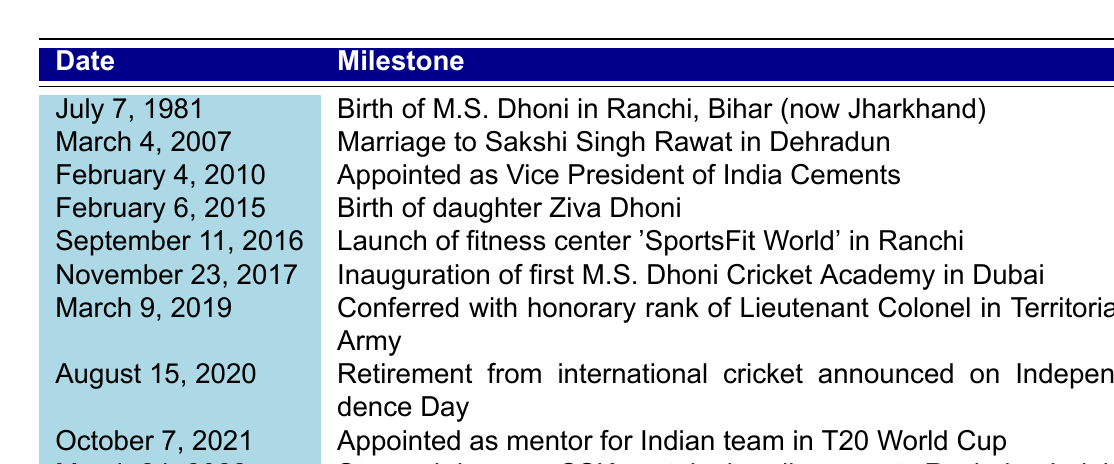What date did M.S. Dhoni get married? The table specifies the date of M.S. Dhoni's marriage as March 4, 2007.
Answer: March 4, 2007 How many years apart are M.S. Dhoni's birth and the birth of his daughter Ziva? M.S. Dhoni was born on July 7, 1981, and Ziva was born on February 6, 2015. The difference in years is 2015 - 1981 = 34 years.
Answer: 34 years Did M.S. Dhoni launch a fitness center? Yes, according to the table, he launched 'SportsFit World' in Ranchi on September 11, 2016.
Answer: Yes When was M.S. Dhoni appointed as Vice President of India Cements? The table shows that M.S. Dhoni was appointed on February 4, 2010.
Answer: February 4, 2010 How many milestones listed happened before 2015? The milestones prior to 2015 are: Birth (1981), Marriage (2007), Vice President appointment (2010), and Ziva's birth (2015). Hence, there are 3 milestones before 2015.
Answer: 3 What was the last major event in M.S. Dhoni's personal life according to the table? The last major event listed is that he stepped down as CSK captain on March 24, 2022.
Answer: March 24, 2022 Was M.S. Dhoni conferred an honorary military rank? Yes, he was conferred the honorary rank of Lieutenant Colonel on March 9, 2019.
Answer: Yes How long after his daughter's birth did he announce his retirement from international cricket? Ziva was born on February 6, 2015, and he retired on August 15, 2020. The duration between these two dates is 5 years and about 6 months.
Answer: 5 years and 6 months What significant career change did M.S. Dhoni undergo on October 7, 2021? On October 7, 2021, he was appointed as a mentor for the Indian team in the T20 World Cup.
Answer: Appointed as mentor for Indian team Which milestone related to cricket academies took place first, and when? The inauguration of the first M.S. Dhoni Cricket Academy occurred on November 23, 2017, making it the first milestone related to cricket academies on this list.
Answer: November 23, 2017 